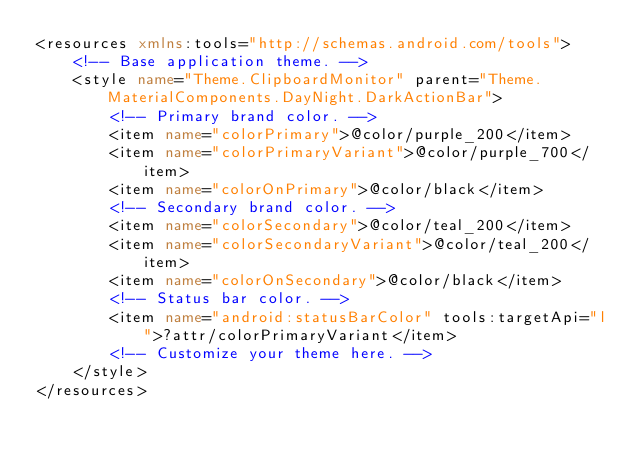Convert code to text. <code><loc_0><loc_0><loc_500><loc_500><_XML_><resources xmlns:tools="http://schemas.android.com/tools">
    <!-- Base application theme. -->
    <style name="Theme.ClipboardMonitor" parent="Theme.MaterialComponents.DayNight.DarkActionBar">
        <!-- Primary brand color. -->
        <item name="colorPrimary">@color/purple_200</item>
        <item name="colorPrimaryVariant">@color/purple_700</item>
        <item name="colorOnPrimary">@color/black</item>
        <!-- Secondary brand color. -->
        <item name="colorSecondary">@color/teal_200</item>
        <item name="colorSecondaryVariant">@color/teal_200</item>
        <item name="colorOnSecondary">@color/black</item>
        <!-- Status bar color. -->
        <item name="android:statusBarColor" tools:targetApi="l">?attr/colorPrimaryVariant</item>
        <!-- Customize your theme here. -->
    </style>
</resources></code> 